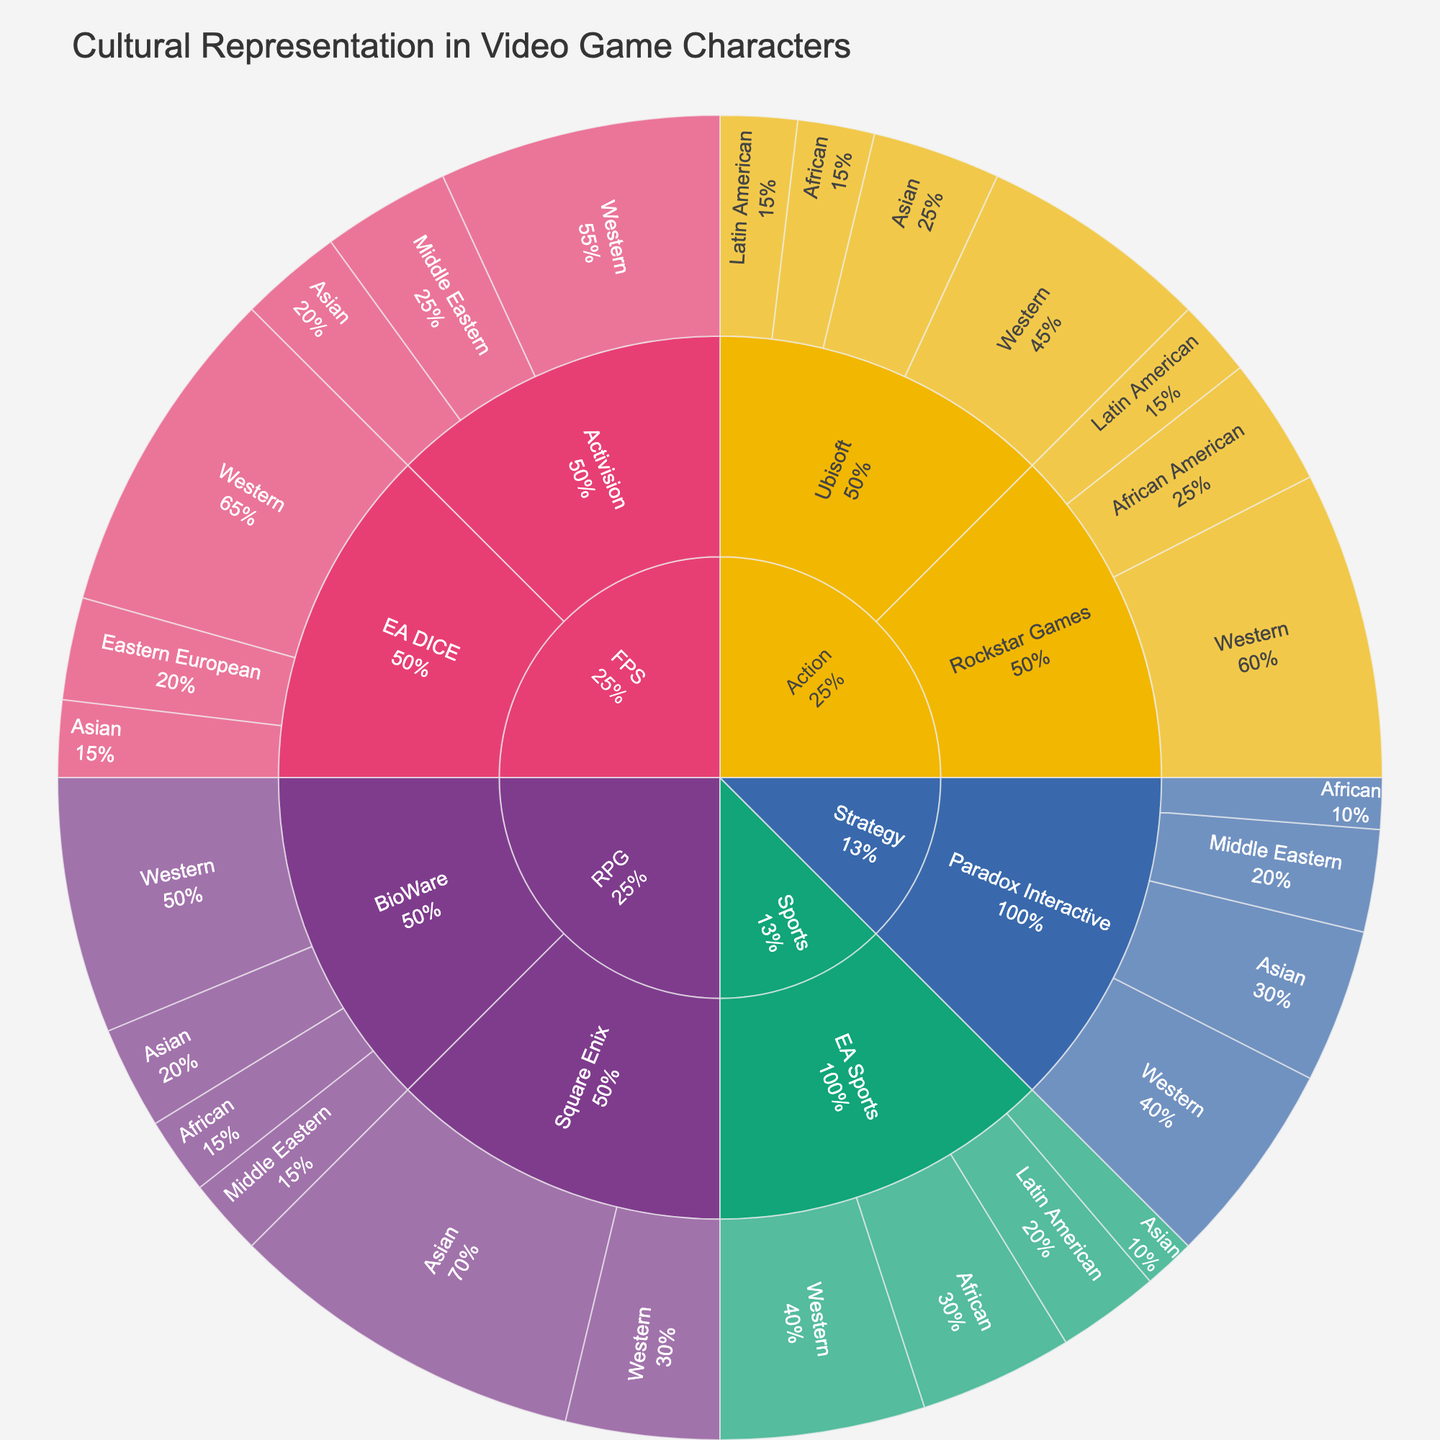What genre shows the highest representation of Western culture? By referring to the outermost ring corresponding to the 'culture' and looking for the largest Western culture segment, we see that Action and FPS are the genres showing high representation, but Action has the largest single segment for Ubisoft.
Answer: Action Which developer has the most diverse cultural representation in the RPG genre? Examine the RPG genre section and identify the developer with the most distinct cultural segments. BioWare displays four cultural segments, more than Square Enix.
Answer: BioWare Compare the percentage representation of African cultures between Ubisoft and Rockstar Games in the Action genre. In the Action genre, Ubisoft has 15% African, while Rockstar Games has 25% African American. Compare these values directly.
Answer: Rockstar Games In terms of cultural representation, which genre has the least diversity? Look for the genre with the fewest distinct cultural segments. RPG with Square Enix showing only Asian and Western culture appears less diverse compared to others.
Answer: RPG What is the combined percentage of Latin American representation in Action and Sports genres? Sum the Latin American percentages from both genres: Action (15% from Ubisoft and 15% from Rockstar Games) and Sports (20% from EA Sports). The total is 15 + 15 + 20.
Answer: 50% How does the cultural representation in Strategy games by Paradox Interactive compare to EA Sports' Sports games? Analyze Paradox Interactive in Strategy against EA Sports in Sports for the number and proportion of represented cultures. Paradox Interactive in Strategy shows four cultures with significant portions, while EA Sports in Sports presents four but with different proportions.
Answer: Similar diversity but different proportions Which developer in the FPS genre has higher representation of Asian culture? Compare the Asian percentages of developers under FPS. Activision has 20%, while EA DICE has 15%.
Answer: Activision Does any developer dominate the representation of Middle Eastern culture? Look at the specific segments under each genre for Middle Eastern representation. Activision in FPS shows 25%, which is the highest among all mentions of Middle Eastern culture.
Answer: Activision What percentage of RPG characters are represented by Middle Eastern culture? Identify the percentage segment labeled Middle Eastern within the RPG genre. BioWare has 15%. Sum the single segment since it is the only one.
Answer: 15% Is there a genre where the Asian culture representation exceeds 50% by any developer? Examine the sections for each genre by developers looking for any Asian culture segments exceeding 50%. In RPG, Square Enix has 70% representation for Asian culture.
Answer: RPG 